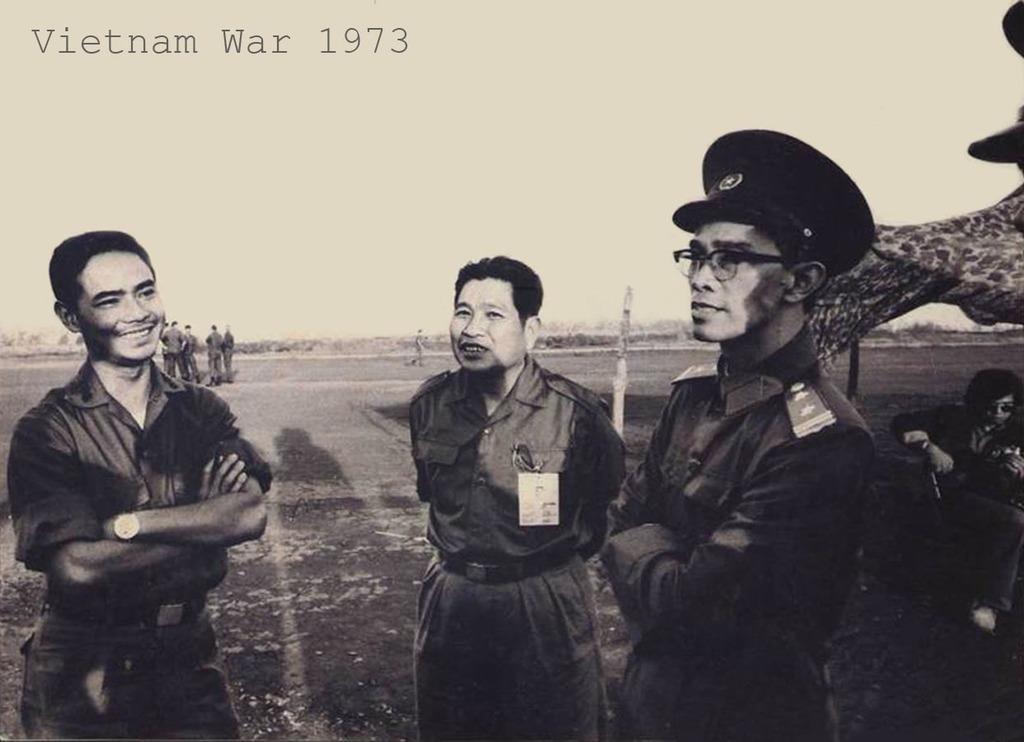Describe this image in one or two sentences. This is a black and white image, in this image in the foreground there are three persons standing and smiling and one person is wearing a hat. In the background there are a group of persons sitting, and at the bottom there is grass. In the background there are some poles and mountains, at the top of the image there is text. 